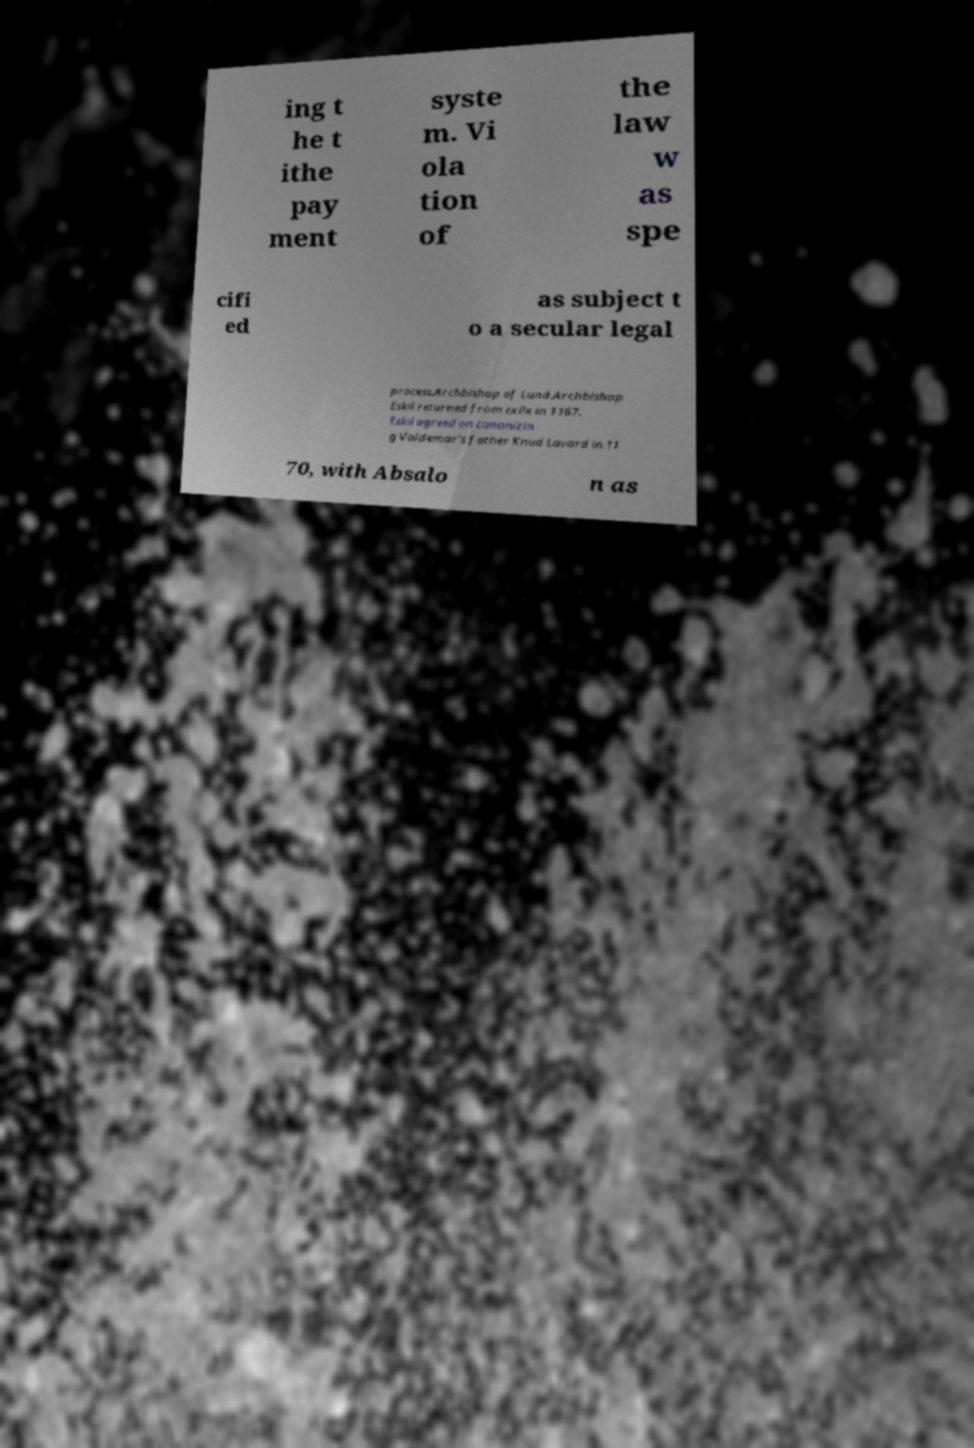Can you read and provide the text displayed in the image?This photo seems to have some interesting text. Can you extract and type it out for me? ing t he t ithe pay ment syste m. Vi ola tion of the law w as spe cifi ed as subject t o a secular legal process.Archbishop of Lund.Archbishop Eskil returned from exile in 1167. Eskil agreed on canonizin g Valdemar's father Knud Lavard in 11 70, with Absalo n as 